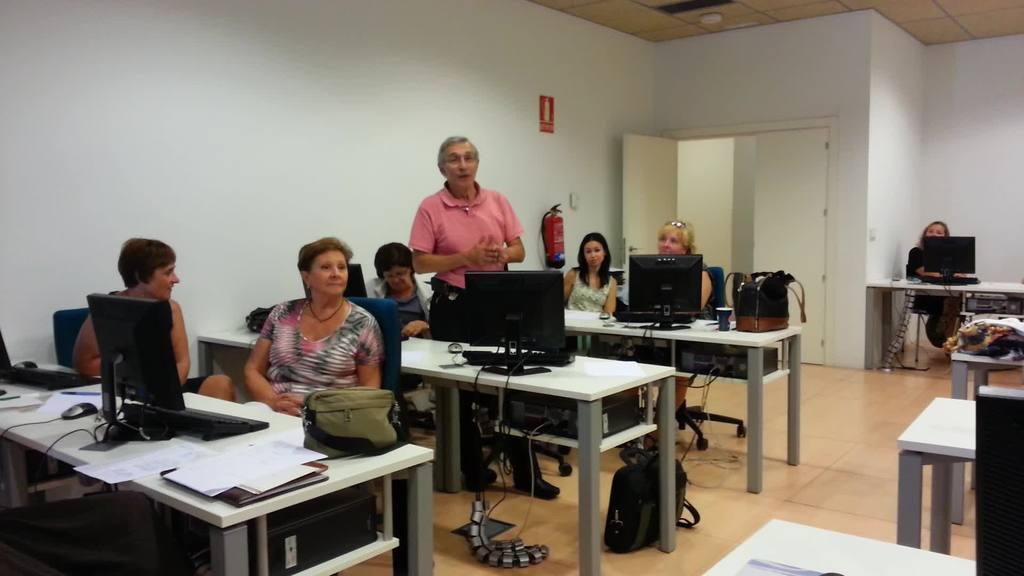Please provide a concise description of this image. In this image there are some people. In them a old man standing. People are arranged at a desk which are placed in a row. There are desktops in front of them and they are eagerly listening to the old man. There is woman at corner of the room. The room has false ceiling. The walls are painted in white. The door is half opened. There is a fire extinguisher beside the door. 